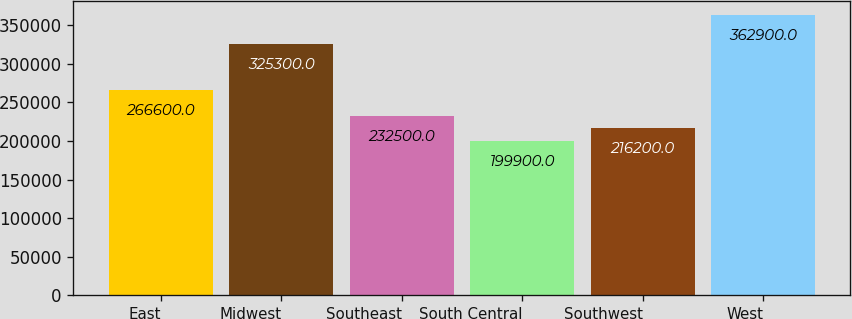<chart> <loc_0><loc_0><loc_500><loc_500><bar_chart><fcel>East<fcel>Midwest<fcel>Southeast<fcel>South Central<fcel>Southwest<fcel>West<nl><fcel>266600<fcel>325300<fcel>232500<fcel>199900<fcel>216200<fcel>362900<nl></chart> 